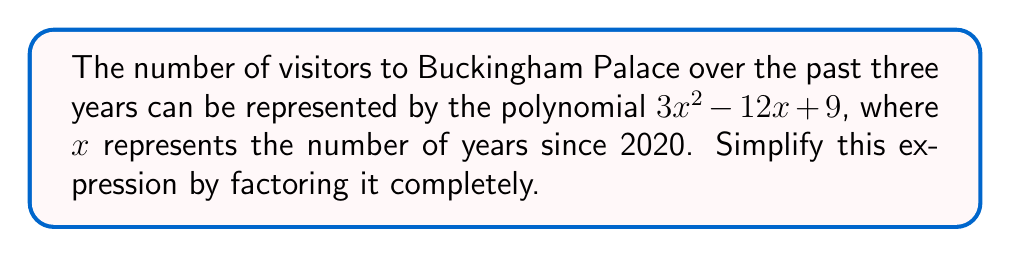Give your solution to this math problem. Let's approach this step-by-step:

1) The polynomial we need to factor is $3x^2 - 12x + 9$

2) First, let's check if there's a common factor:
   $3x^2 - 12x + 9 = 3(x^2 - 4x + 3)$

3) Now we focus on factoring $x^2 - 4x + 3$

4) This is a quadratic expression in the form $ax^2 + bx + c$, where $a=1$, $b=-4$, and $c=3$

5) To factor this, we need to find two numbers that multiply to give $ac$ (which is 3) and add up to $b$ (which is -4)

6) The numbers that satisfy this are -3 and -1

7) So we can rewrite the expression as:
   $x^2 - 3x - x + 3$

8) Grouping these terms:
   $(x^2 - 3x) + (-x + 3)$
   $x(x - 3) - 1(x - 3)$
   $(x - 3)(x - 1)$

9) Putting this back into our original expression:
   $3x^2 - 12x + 9 = 3(x^2 - 4x + 3) = 3(x - 3)(x - 1)$

Therefore, the fully factored expression is $3(x - 3)(x - 1)$.
Answer: $3(x - 3)(x - 1)$ 